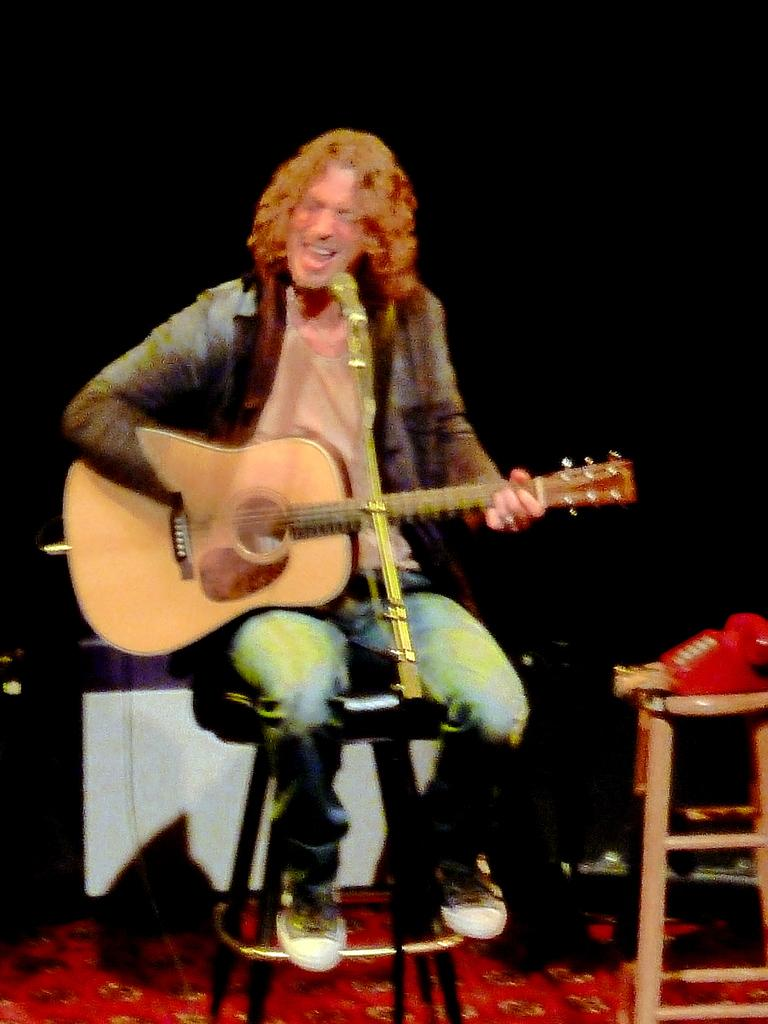Who is the main subject in the image? There is a person in the image. What is the person doing in the image? The person is sitting in front of a mic. What instrument is the person holding? The person is holding a guitar. What type of story is the person telling on stage in the image? There is no stage present in the image, and the person is not telling a story; they are sitting in front of a mic and holding a guitar. 